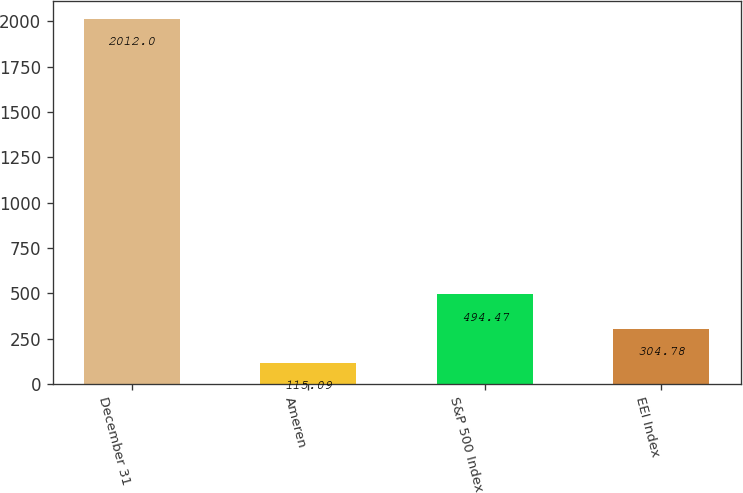<chart> <loc_0><loc_0><loc_500><loc_500><bar_chart><fcel>December 31<fcel>Ameren<fcel>S&P 500 Index<fcel>EEI Index<nl><fcel>2012<fcel>115.09<fcel>494.47<fcel>304.78<nl></chart> 